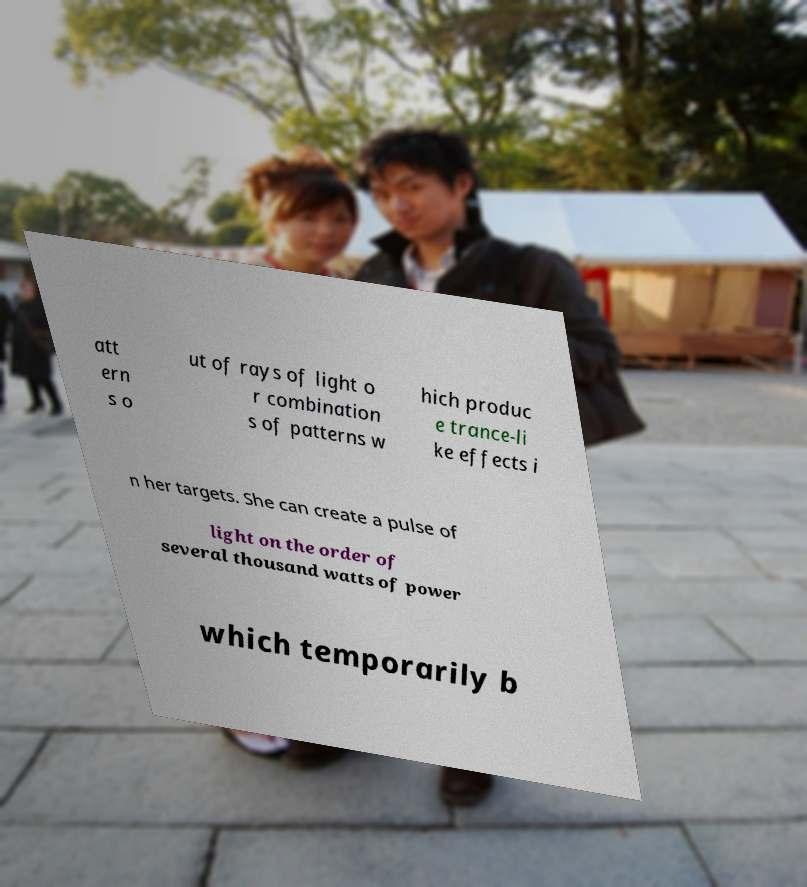For documentation purposes, I need the text within this image transcribed. Could you provide that? att ern s o ut of rays of light o r combination s of patterns w hich produc e trance-li ke effects i n her targets. She can create a pulse of light on the order of several thousand watts of power which temporarily b 